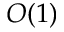<formula> <loc_0><loc_0><loc_500><loc_500>O ( 1 )</formula> 